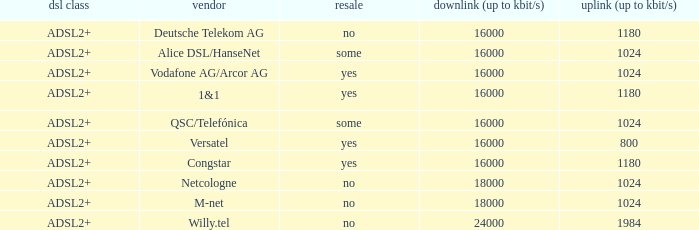How many providers are there where the resale category is yes and bandwith is up is 1024? 1.0. Parse the full table. {'header': ['dsl class', 'vendor', 'resale', 'downlink (up to kbit/s)', 'uplink (up to kbit/s)'], 'rows': [['ADSL2+', 'Deutsche Telekom AG', 'no', '16000', '1180'], ['ADSL2+', 'Alice DSL/HanseNet', 'some', '16000', '1024'], ['ADSL2+', 'Vodafone AG/Arcor AG', 'yes', '16000', '1024'], ['ADSL2+', '1&1', 'yes', '16000', '1180'], ['ADSL2+', 'QSC/Telefónica', 'some', '16000', '1024'], ['ADSL2+', 'Versatel', 'yes', '16000', '800'], ['ADSL2+', 'Congstar', 'yes', '16000', '1180'], ['ADSL2+', 'Netcologne', 'no', '18000', '1024'], ['ADSL2+', 'M-net', 'no', '18000', '1024'], ['ADSL2+', 'Willy.tel', 'no', '24000', '1984']]} 